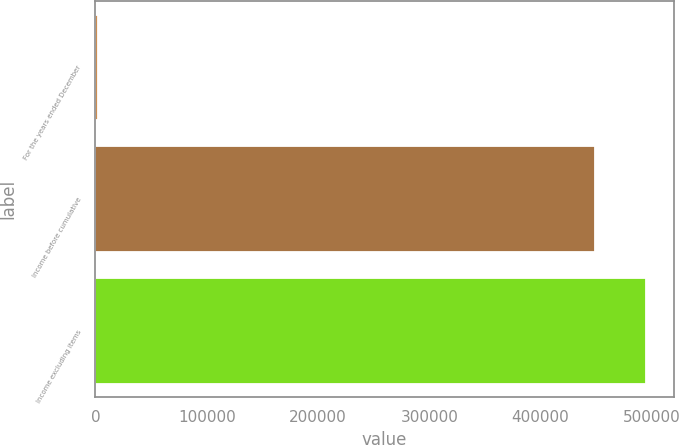Convert chart to OTSL. <chart><loc_0><loc_0><loc_500><loc_500><bar_chart><fcel>For the years ended December<fcel>Income before cumulative<fcel>Income excluding items<nl><fcel>2003<fcel>449315<fcel>495024<nl></chart> 